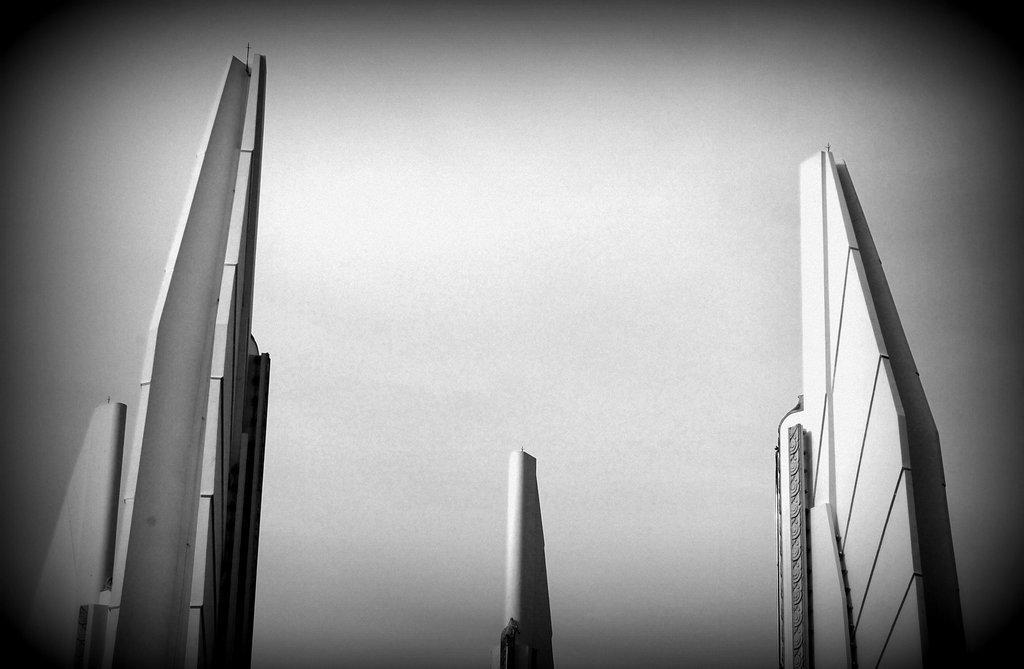How would you summarize this image in a sentence or two? In this image we can see buildings, also we can see the sky, and the picture is taken in black and white mode. 